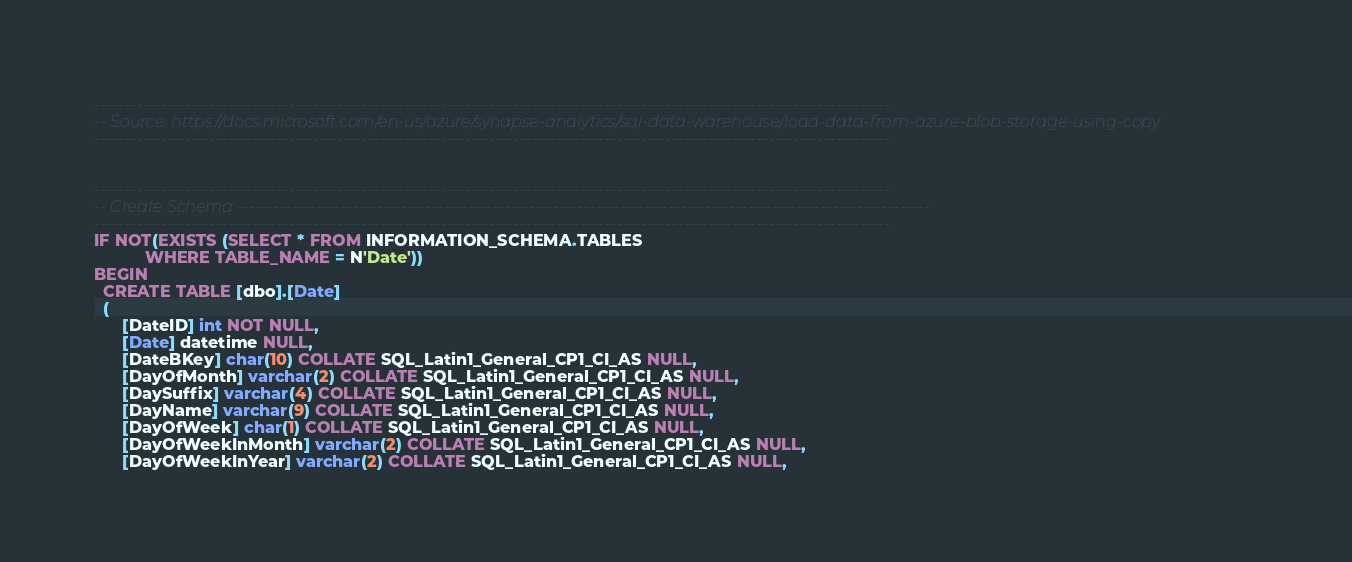<code> <loc_0><loc_0><loc_500><loc_500><_SQL_>-----------------------------------------------------------------------------------------------------------------------------------
-- Source: https://docs.microsoft.com/en-us/azure/synapse-analytics/sql-data-warehouse/load-data-from-azure-blob-storage-using-copy
-----------------------------------------------------------------------------------------------------------------------------------


-----------------------------------------------------------------------------------------------------------------------------------
-- Create Schema ------------------------------------------------------------------------------------------------------------------
-----------------------------------------------------------------------------------------------------------------------------------
IF NOT(EXISTS (SELECT * FROM INFORMATION_SCHEMA.TABLES
           WHERE TABLE_NAME = N'Date'))
BEGIN
  CREATE TABLE [dbo].[Date]
  (
      [DateID] int NOT NULL,
      [Date] datetime NULL,
      [DateBKey] char(10) COLLATE SQL_Latin1_General_CP1_CI_AS NULL,
      [DayOfMonth] varchar(2) COLLATE SQL_Latin1_General_CP1_CI_AS NULL,
      [DaySuffix] varchar(4) COLLATE SQL_Latin1_General_CP1_CI_AS NULL,
      [DayName] varchar(9) COLLATE SQL_Latin1_General_CP1_CI_AS NULL,
      [DayOfWeek] char(1) COLLATE SQL_Latin1_General_CP1_CI_AS NULL,
      [DayOfWeekInMonth] varchar(2) COLLATE SQL_Latin1_General_CP1_CI_AS NULL,
      [DayOfWeekInYear] varchar(2) COLLATE SQL_Latin1_General_CP1_CI_AS NULL,</code> 